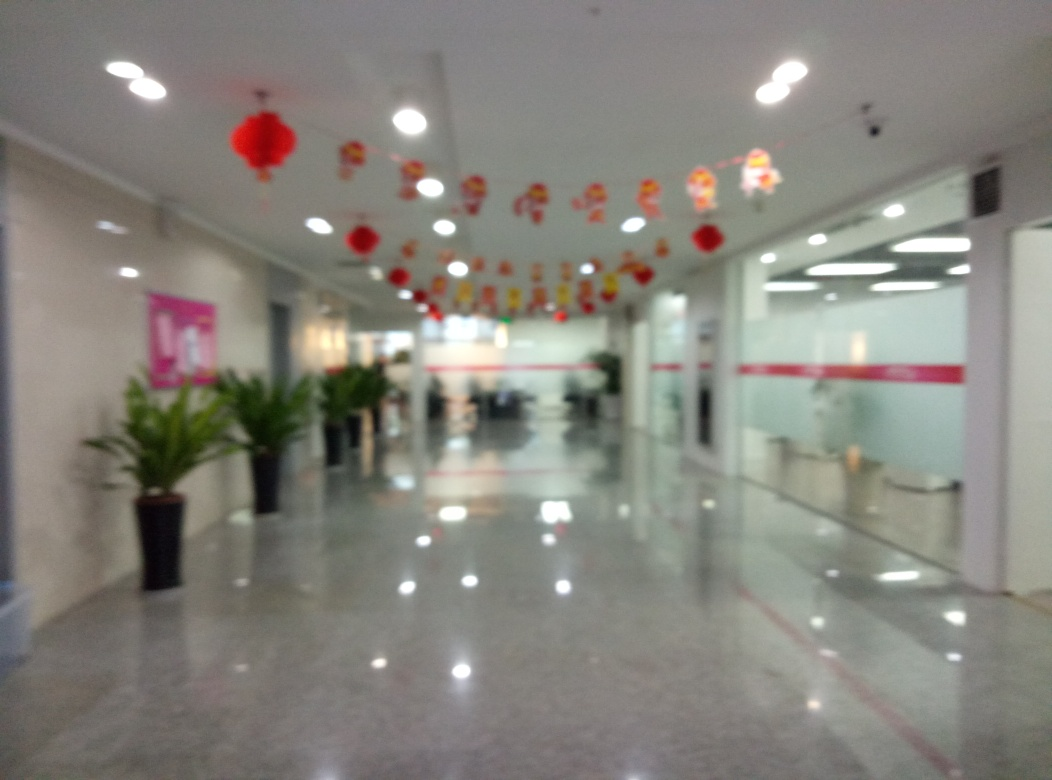Can you tell what time of day it might be in this image? Without any windows or natural light sources visible, determining the exact time of day is difficult. The artificial lighting does seem to be the primary source of illumination, which could suggest an evening setting or simply an area without direct sunlight. What elements in this image could be enhanced to improve its visual appeal? Improving the image's focus would greatly enhance its visual appeal, allowing for the finer details of the decorations and architecture to be appreciated. Additionally, adding more color variations or plants might provide warmer and more welcoming aesthetics. 